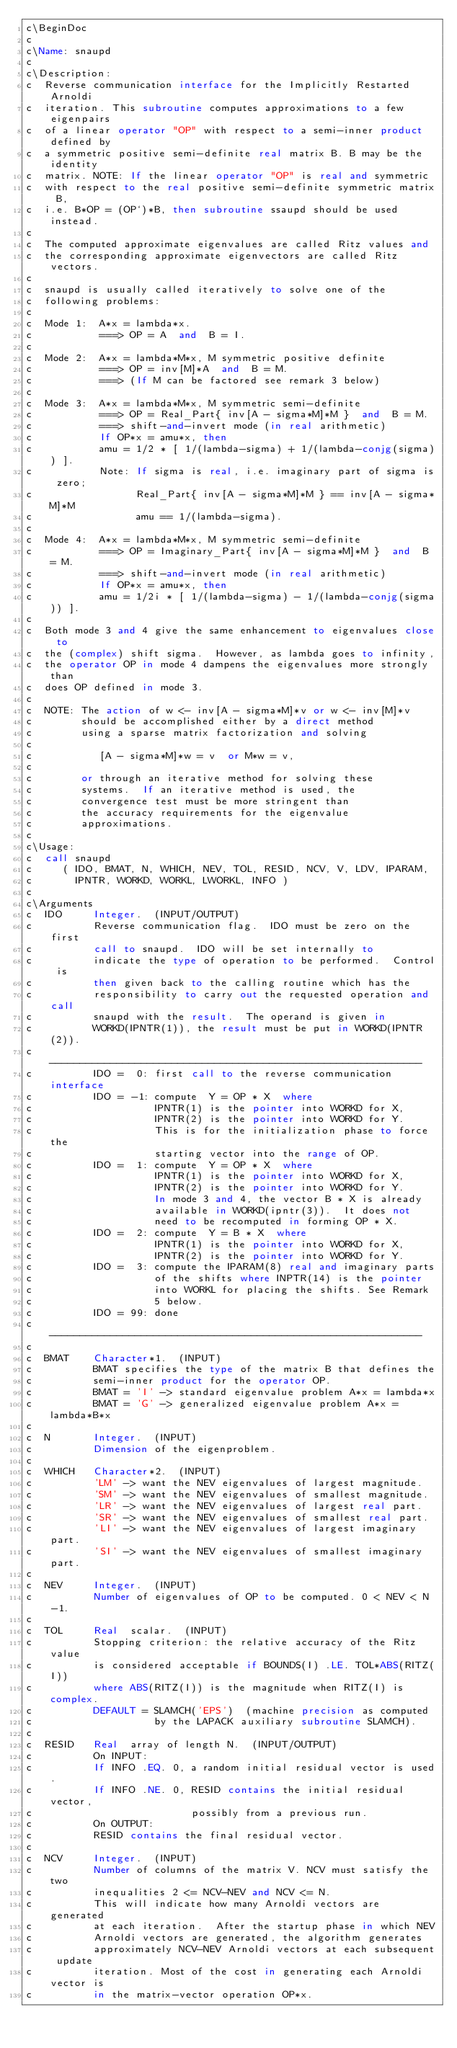Convert code to text. <code><loc_0><loc_0><loc_500><loc_500><_FORTRAN_>c\BeginDoc
c
c\Name: snaupd
c
c\Description: 
c  Reverse communication interface for the Implicitly Restarted Arnoldi
c  iteration. This subroutine computes approximations to a few eigenpairs 
c  of a linear operator "OP" with respect to a semi-inner product defined by 
c  a symmetric positive semi-definite real matrix B. B may be the identity 
c  matrix. NOTE: If the linear operator "OP" is real and symmetric 
c  with respect to the real positive semi-definite symmetric matrix B, 
c  i.e. B*OP = (OP`)*B, then subroutine ssaupd should be used instead.
c
c  The computed approximate eigenvalues are called Ritz values and
c  the corresponding approximate eigenvectors are called Ritz vectors.
c
c  snaupd is usually called iteratively to solve one of the 
c  following problems:
c
c  Mode 1:  A*x = lambda*x.
c           ===> OP = A  and  B = I.
c
c  Mode 2:  A*x = lambda*M*x, M symmetric positive definite
c           ===> OP = inv[M]*A  and  B = M.
c           ===> (If M can be factored see remark 3 below)
c
c  Mode 3:  A*x = lambda*M*x, M symmetric semi-definite
c           ===> OP = Real_Part{ inv[A - sigma*M]*M }  and  B = M. 
c           ===> shift-and-invert mode (in real arithmetic)
c           If OP*x = amu*x, then 
c           amu = 1/2 * [ 1/(lambda-sigma) + 1/(lambda-conjg(sigma)) ].
c           Note: If sigma is real, i.e. imaginary part of sigma is zero;
c                 Real_Part{ inv[A - sigma*M]*M } == inv[A - sigma*M]*M 
c                 amu == 1/(lambda-sigma). 
c  
c  Mode 4:  A*x = lambda*M*x, M symmetric semi-definite
c           ===> OP = Imaginary_Part{ inv[A - sigma*M]*M }  and  B = M. 
c           ===> shift-and-invert mode (in real arithmetic)
c           If OP*x = amu*x, then 
c           amu = 1/2i * [ 1/(lambda-sigma) - 1/(lambda-conjg(sigma)) ].
c
c  Both mode 3 and 4 give the same enhancement to eigenvalues close to
c  the (complex) shift sigma.  However, as lambda goes to infinity,
c  the operator OP in mode 4 dampens the eigenvalues more strongly than
c  does OP defined in mode 3.
c
c  NOTE: The action of w <- inv[A - sigma*M]*v or w <- inv[M]*v
c        should be accomplished either by a direct method
c        using a sparse matrix factorization and solving
c
c           [A - sigma*M]*w = v  or M*w = v,
c
c        or through an iterative method for solving these
c        systems.  If an iterative method is used, the
c        convergence test must be more stringent than
c        the accuracy requirements for the eigenvalue
c        approximations.
c
c\Usage:
c  call snaupd
c     ( IDO, BMAT, N, WHICH, NEV, TOL, RESID, NCV, V, LDV, IPARAM,
c       IPNTR, WORKD, WORKL, LWORKL, INFO )
c
c\Arguments
c  IDO     Integer.  (INPUT/OUTPUT)
c          Reverse communication flag.  IDO must be zero on the first 
c          call to snaupd.  IDO will be set internally to
c          indicate the type of operation to be performed.  Control is
c          then given back to the calling routine which has the
c          responsibility to carry out the requested operation and call
c          snaupd with the result.  The operand is given in
c          WORKD(IPNTR(1)), the result must be put in WORKD(IPNTR(2)).
c          -------------------------------------------------------------
c          IDO =  0: first call to the reverse communication interface
c          IDO = -1: compute  Y = OP * X  where
c                    IPNTR(1) is the pointer into WORKD for X,
c                    IPNTR(2) is the pointer into WORKD for Y.
c                    This is for the initialization phase to force the
c                    starting vector into the range of OP.
c          IDO =  1: compute  Y = OP * X  where
c                    IPNTR(1) is the pointer into WORKD for X,
c                    IPNTR(2) is the pointer into WORKD for Y.
c                    In mode 3 and 4, the vector B * X is already
c                    available in WORKD(ipntr(3)).  It does not
c                    need to be recomputed in forming OP * X.
c          IDO =  2: compute  Y = B * X  where
c                    IPNTR(1) is the pointer into WORKD for X,
c                    IPNTR(2) is the pointer into WORKD for Y.
c          IDO =  3: compute the IPARAM(8) real and imaginary parts 
c                    of the shifts where INPTR(14) is the pointer
c                    into WORKL for placing the shifts. See Remark
c                    5 below.
c          IDO = 99: done
c          -------------------------------------------------------------
c             
c  BMAT    Character*1.  (INPUT)
c          BMAT specifies the type of the matrix B that defines the
c          semi-inner product for the operator OP.
c          BMAT = 'I' -> standard eigenvalue problem A*x = lambda*x
c          BMAT = 'G' -> generalized eigenvalue problem A*x = lambda*B*x
c
c  N       Integer.  (INPUT)
c          Dimension of the eigenproblem.
c
c  WHICH   Character*2.  (INPUT)
c          'LM' -> want the NEV eigenvalues of largest magnitude.
c          'SM' -> want the NEV eigenvalues of smallest magnitude.
c          'LR' -> want the NEV eigenvalues of largest real part.
c          'SR' -> want the NEV eigenvalues of smallest real part.
c          'LI' -> want the NEV eigenvalues of largest imaginary part.
c          'SI' -> want the NEV eigenvalues of smallest imaginary part.
c
c  NEV     Integer.  (INPUT)
c          Number of eigenvalues of OP to be computed. 0 < NEV < N-1.
c
c  TOL     Real  scalar.  (INPUT)
c          Stopping criterion: the relative accuracy of the Ritz value 
c          is considered acceptable if BOUNDS(I) .LE. TOL*ABS(RITZ(I))
c          where ABS(RITZ(I)) is the magnitude when RITZ(I) is complex.
c          DEFAULT = SLAMCH('EPS')  (machine precision as computed
c                    by the LAPACK auxiliary subroutine SLAMCH).
c
c  RESID   Real  array of length N.  (INPUT/OUTPUT)
c          On INPUT: 
c          If INFO .EQ. 0, a random initial residual vector is used.
c          If INFO .NE. 0, RESID contains the initial residual vector,
c                          possibly from a previous run.
c          On OUTPUT:
c          RESID contains the final residual vector.
c
c  NCV     Integer.  (INPUT)
c          Number of columns of the matrix V. NCV must satisfy the two
c          inequalities 2 <= NCV-NEV and NCV <= N.
c          This will indicate how many Arnoldi vectors are generated 
c          at each iteration.  After the startup phase in which NEV 
c          Arnoldi vectors are generated, the algorithm generates 
c          approximately NCV-NEV Arnoldi vectors at each subsequent update 
c          iteration. Most of the cost in generating each Arnoldi vector is 
c          in the matrix-vector operation OP*x. </code> 